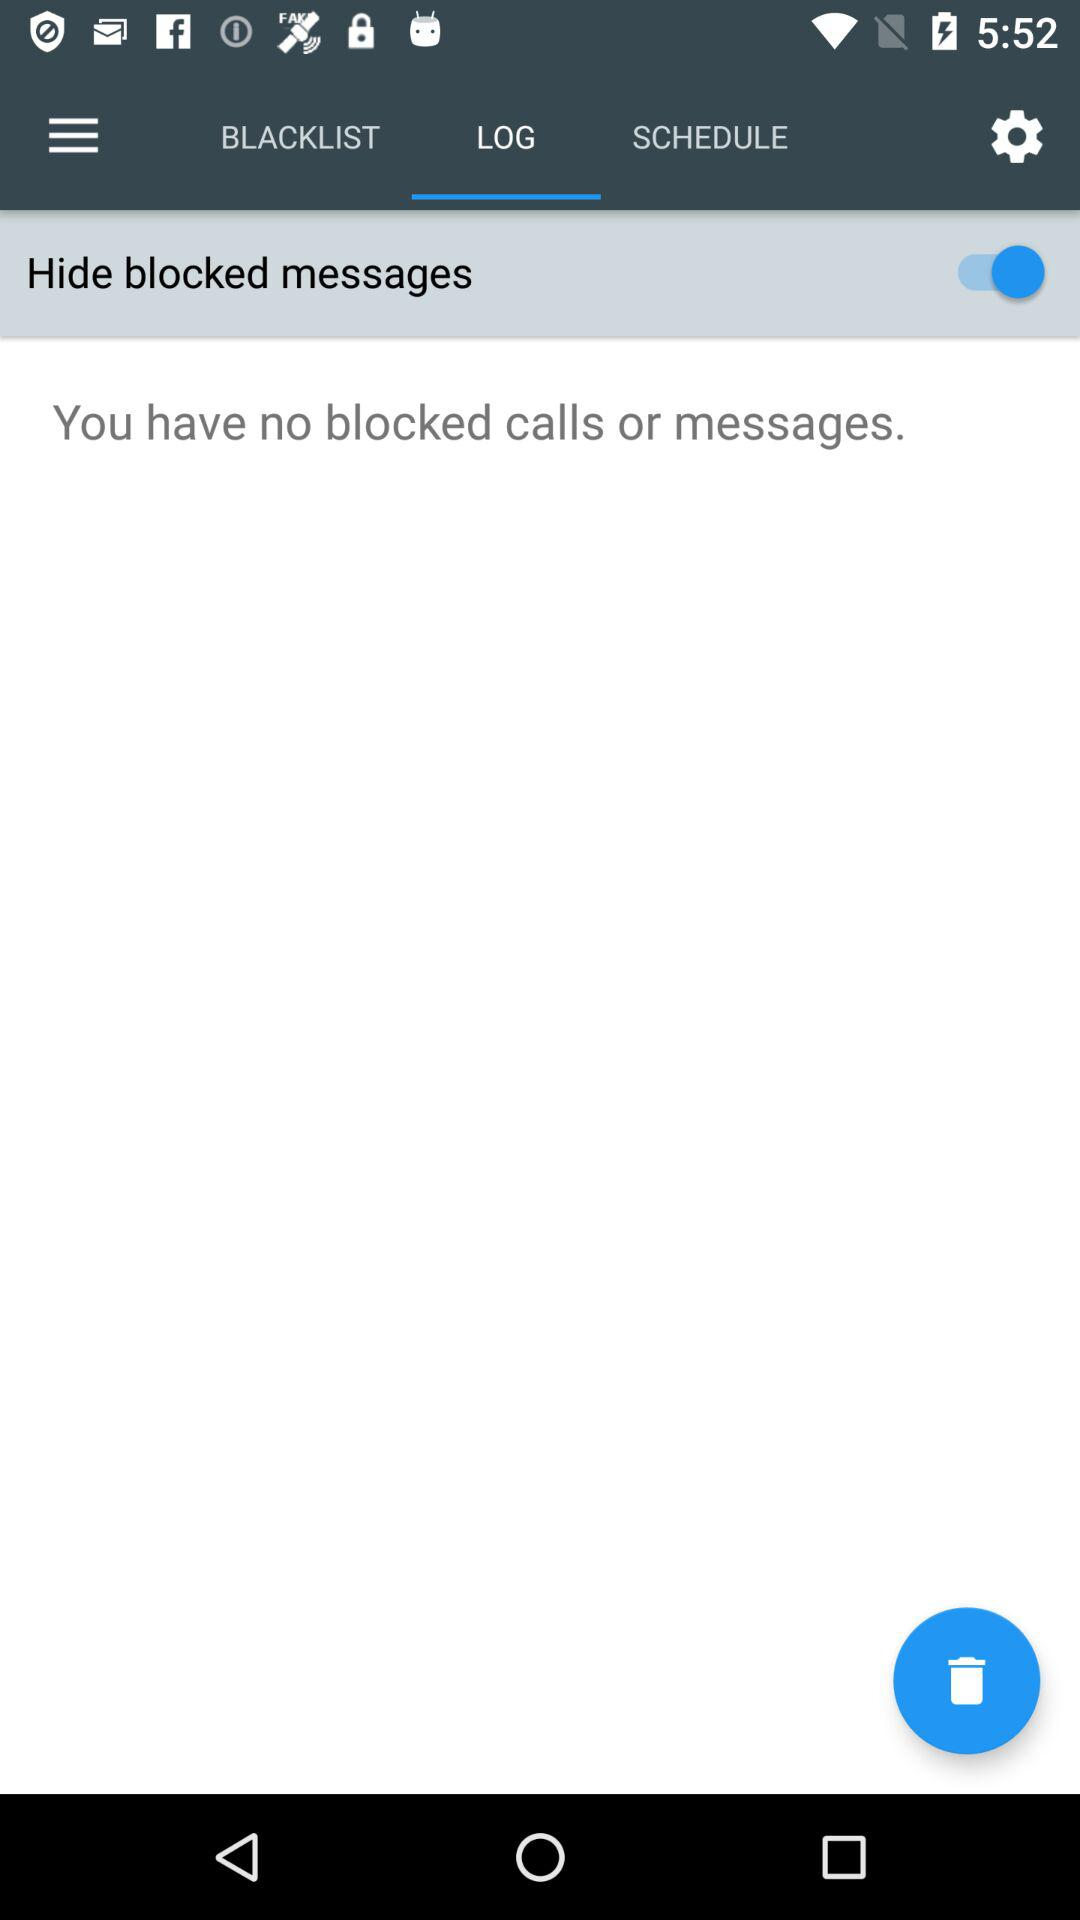How many blocked calls or messages are there?
Answer the question using a single word or phrase. 0 